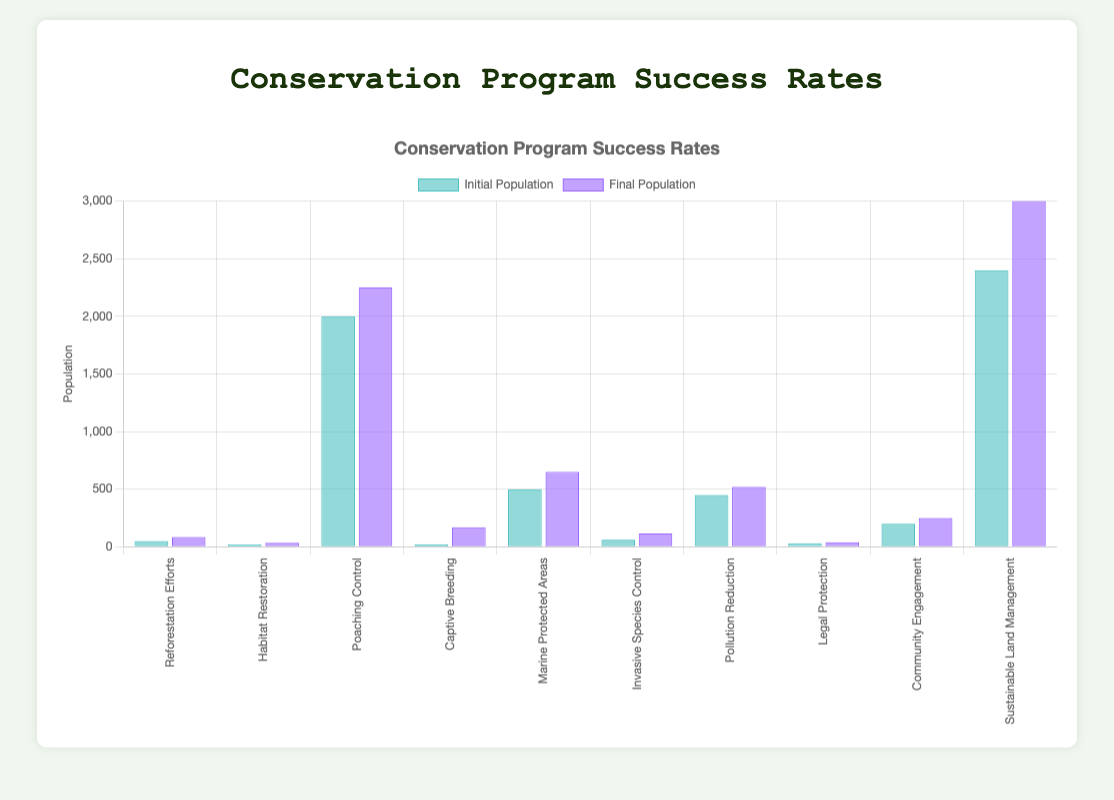What is the highest initial population among the conservation programs? By observing the height of the bars representing the initial population, the tallest bar corresponds to the "Sustainable Land Management" program for the Black Rhino with an initial population of 2400.
Answer: 2400 Which conservation program had the greatest increase in population? The chart shows both the initial and final populations of each species. The "Captive Breeding" program for the California Condor shows the greatest increase from 22 to 170, which is an increase of 148.
Answer: Captive Breeding What is the average final population of the species involved in the conservation programs? Sum the final populations (85 + 35 + 2250 + 170 + 650 + 116 + 520 + 40 + 250 + 3000) and divide by the number of programs (10). This equals (85 + 35 + 2250 + 170 + 650 + 116 + 520 + 40 + 250 + 3000) / 10 = 7116 / 10.
Answer: 711.6 Which program had a lower final population compared to its initial population? All programs show bars where the final population is higher than the initial one, indicating none had a lower final population.
Answer: None Which species experienced the smallest percentage increase in population? Calculate the percentage increases and compare them. The smallest increase is for the "Poaching Control" program for the African Elephant, with an increase from 2000 to 2250, which is a 12.5% increase.
Answer: African Elephant What is the combined final population of the species in the "Habitat Restoration" and "Legal Protection" programs? Add the final populations of the Florida Panther (35) and the Amur Leopard (40). This results in 35 + 40 = 75.
Answer: 75 How much greater is the success rate of "Captive Breeding" compared to "Pollution Reduction"? The "Captive Breeding" program has a success rate of 672.73%, while the "Pollution Reduction" program has a success rate of 15.56%. The difference is 672.73 - 15.56 = 657.17%.
Answer: 657.17% Which color represents the initial populations in the bar chart? Observing the legend in the chart, the initial population is represented by bars colored in a shade of green.
Answer: Green What is the total initial population for all species combined? Sum all the initial populations: 50 + 20 + 2000 + 22 + 500 + 62 + 450 + 30 + 200 + 2400 which equals 5734.
Answer: 5734 Which conservation program shows the tallest bar for the final population? The tallest bar represents the "Sustainable Land Management" program for the Black Rhino with a final population of 3000.
Answer: Sustainable Land Management 